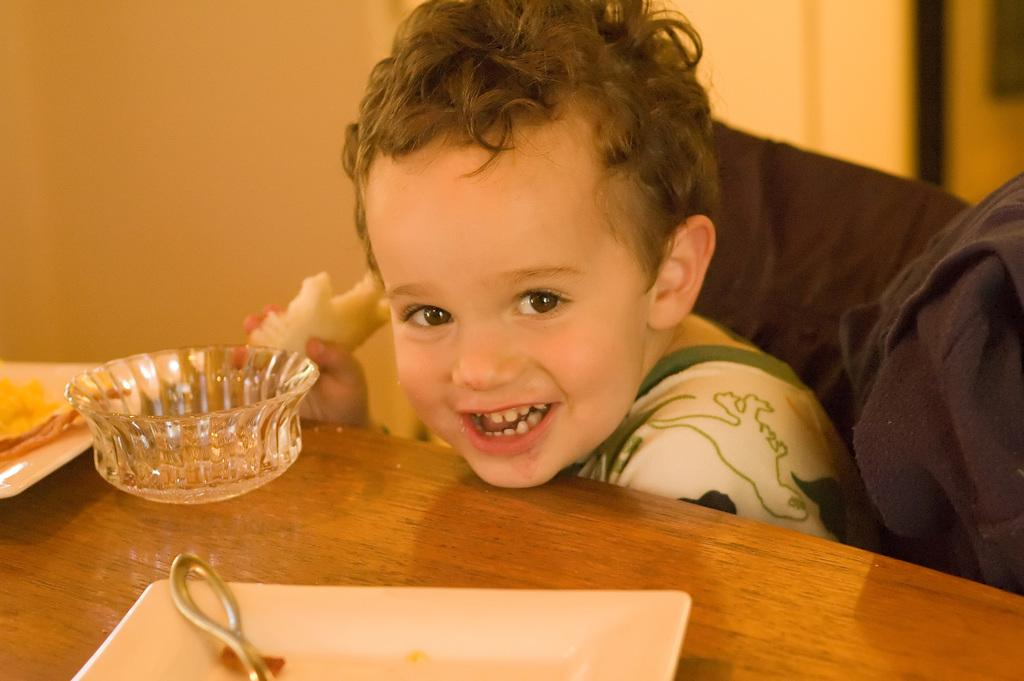What is the main subject of the image? There is a baby in the image. What is the baby doing in the image? The baby is sitting. Where is the baby located in relation to the table? The baby is in front of a table. What can be seen on the table in the image? There are objects placed on the table. What color is the girl's hair in the image? There is no girl present in the image; it features a baby. What type of ink is being used to write on the stove in the image? There is no ink or stove present in the image. 